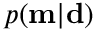<formula> <loc_0><loc_0><loc_500><loc_500>p ( m | d )</formula> 